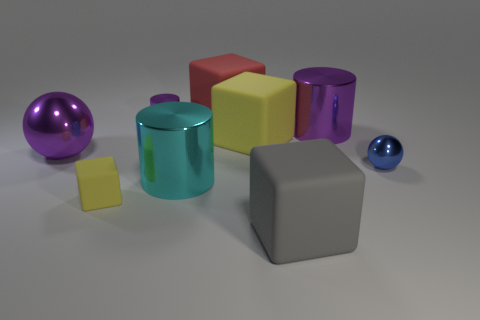How many gray blocks have the same material as the blue sphere?
Your answer should be compact. 0. There is a cylinder to the right of the rubber thing behind the big purple metallic cylinder; is there a blue sphere that is behind it?
Give a very brief answer. No. How many balls are tiny cyan matte objects or tiny yellow rubber objects?
Provide a succinct answer. 0. There is a big cyan object; does it have the same shape as the big object that is left of the large cyan cylinder?
Provide a succinct answer. No. Is the number of balls that are to the right of the cyan object less than the number of tiny blue shiny objects?
Give a very brief answer. No. There is a big red matte thing; are there any gray objects left of it?
Offer a very short reply. No. Is there a small blue object that has the same shape as the red thing?
Your answer should be compact. No. What shape is the gray rubber thing that is the same size as the red matte thing?
Provide a short and direct response. Cube. How many things are big purple objects that are to the right of the big yellow rubber cube or tiny red matte spheres?
Keep it short and to the point. 1. Do the small metallic cylinder and the large metallic sphere have the same color?
Offer a terse response. Yes. 